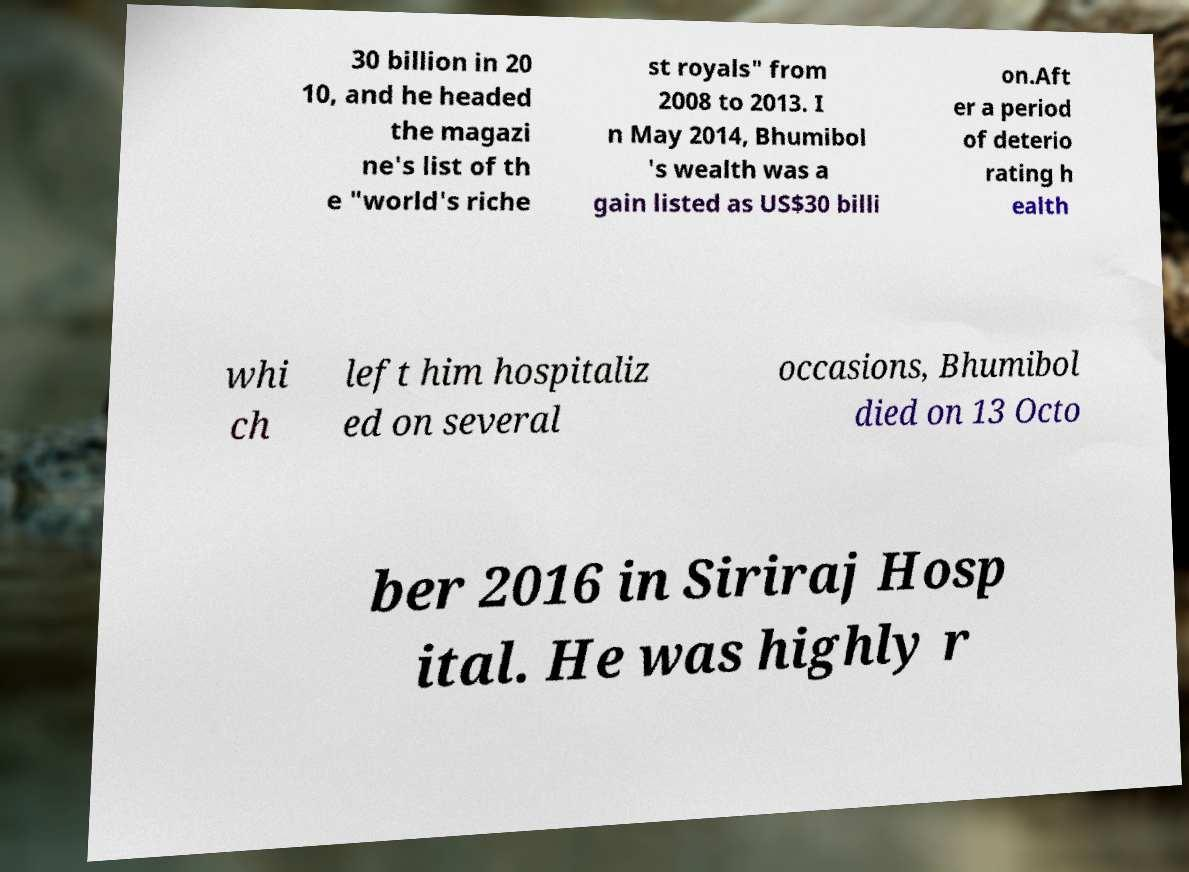Please identify and transcribe the text found in this image. 30 billion in 20 10, and he headed the magazi ne's list of th e "world's riche st royals" from 2008 to 2013. I n May 2014, Bhumibol 's wealth was a gain listed as US$30 billi on.Aft er a period of deterio rating h ealth whi ch left him hospitaliz ed on several occasions, Bhumibol died on 13 Octo ber 2016 in Siriraj Hosp ital. He was highly r 